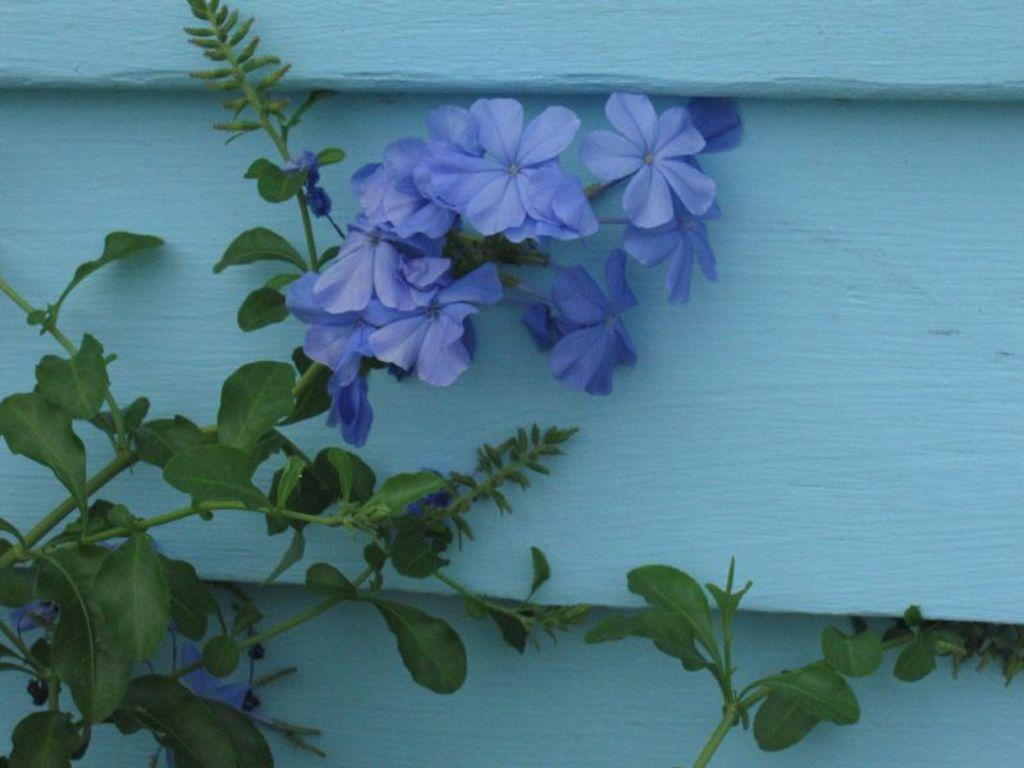What is present in the image? There is a plant in the image. What can be observed about the plant's flower? The plant has a purple flower. What color is the wall behind the plant? There is a blue color wall behind the plant. What type of organization is responsible for the plant's development in the image? There is no information about any organization or development in the image; it simply shows a plant with a purple flower in front of a blue wall. 